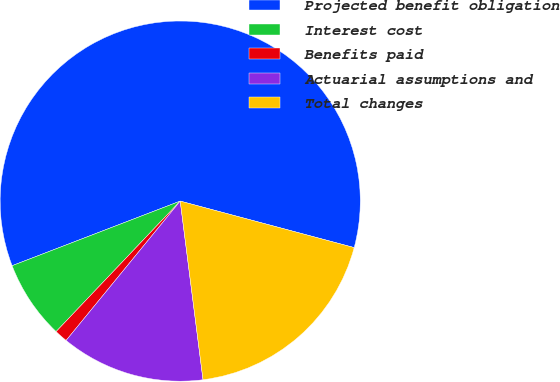Convert chart to OTSL. <chart><loc_0><loc_0><loc_500><loc_500><pie_chart><fcel>Projected benefit obligation<fcel>Interest cost<fcel>Benefits paid<fcel>Actuarial assumptions and<fcel>Total changes<nl><fcel>59.99%<fcel>7.06%<fcel>1.18%<fcel>12.94%<fcel>18.82%<nl></chart> 